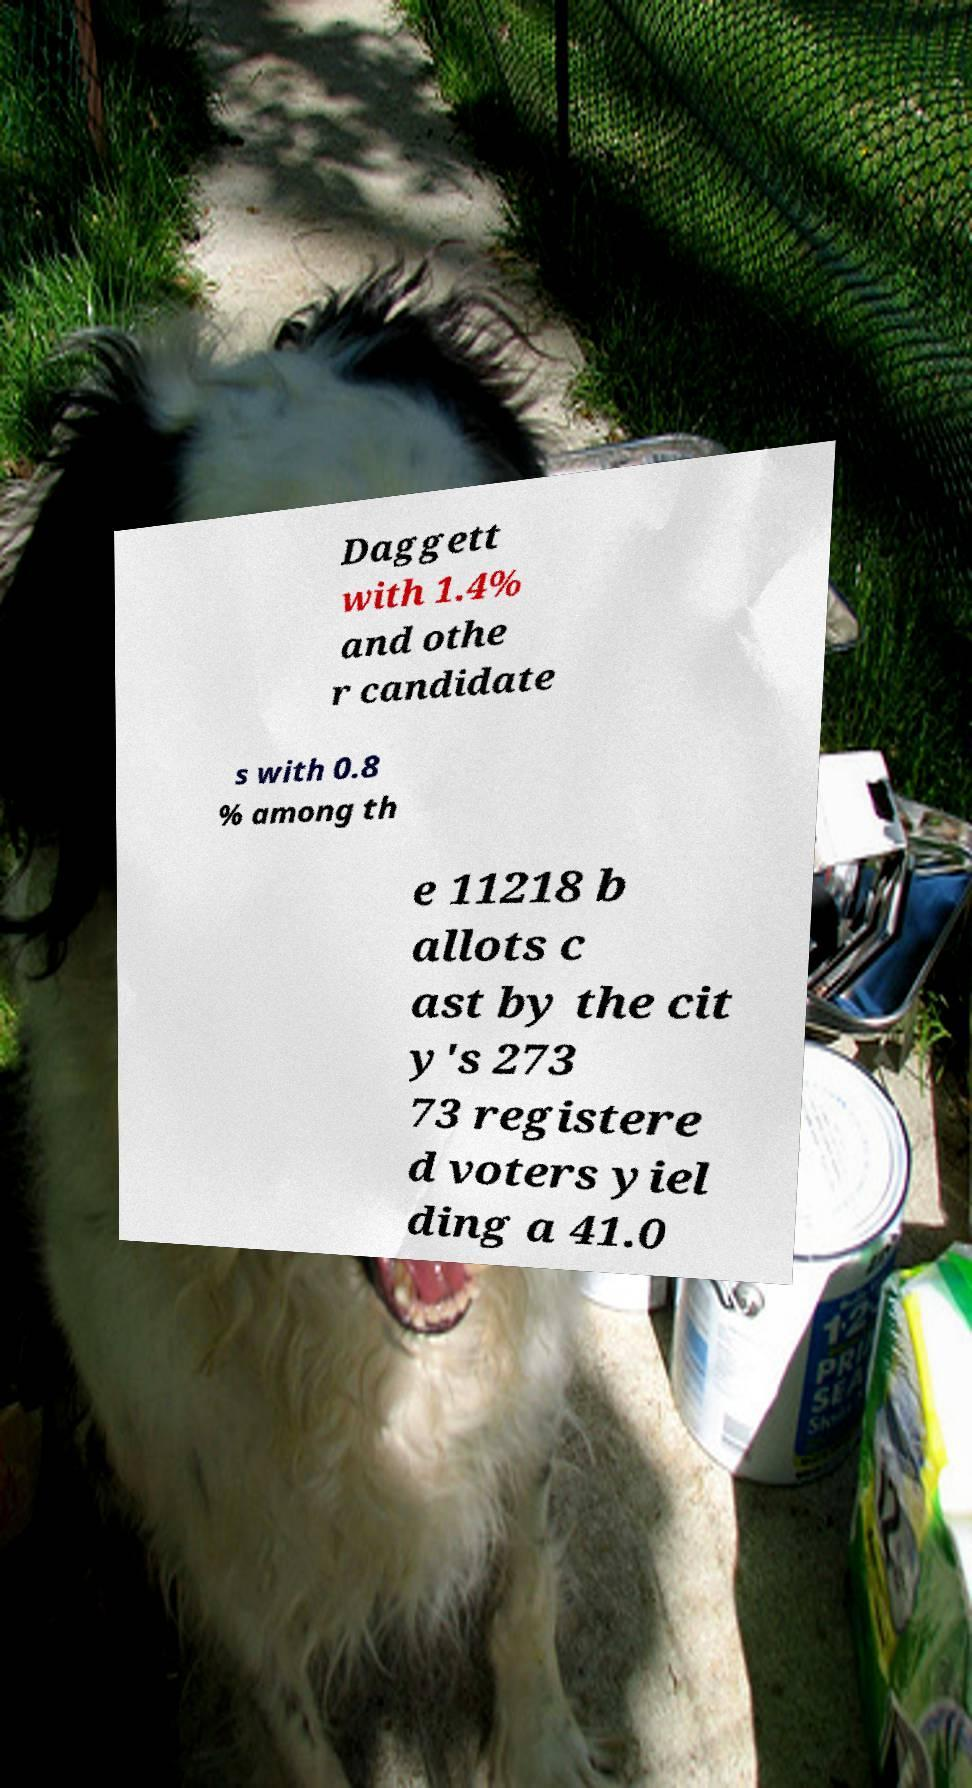Can you accurately transcribe the text from the provided image for me? Daggett with 1.4% and othe r candidate s with 0.8 % among th e 11218 b allots c ast by the cit y's 273 73 registere d voters yiel ding a 41.0 